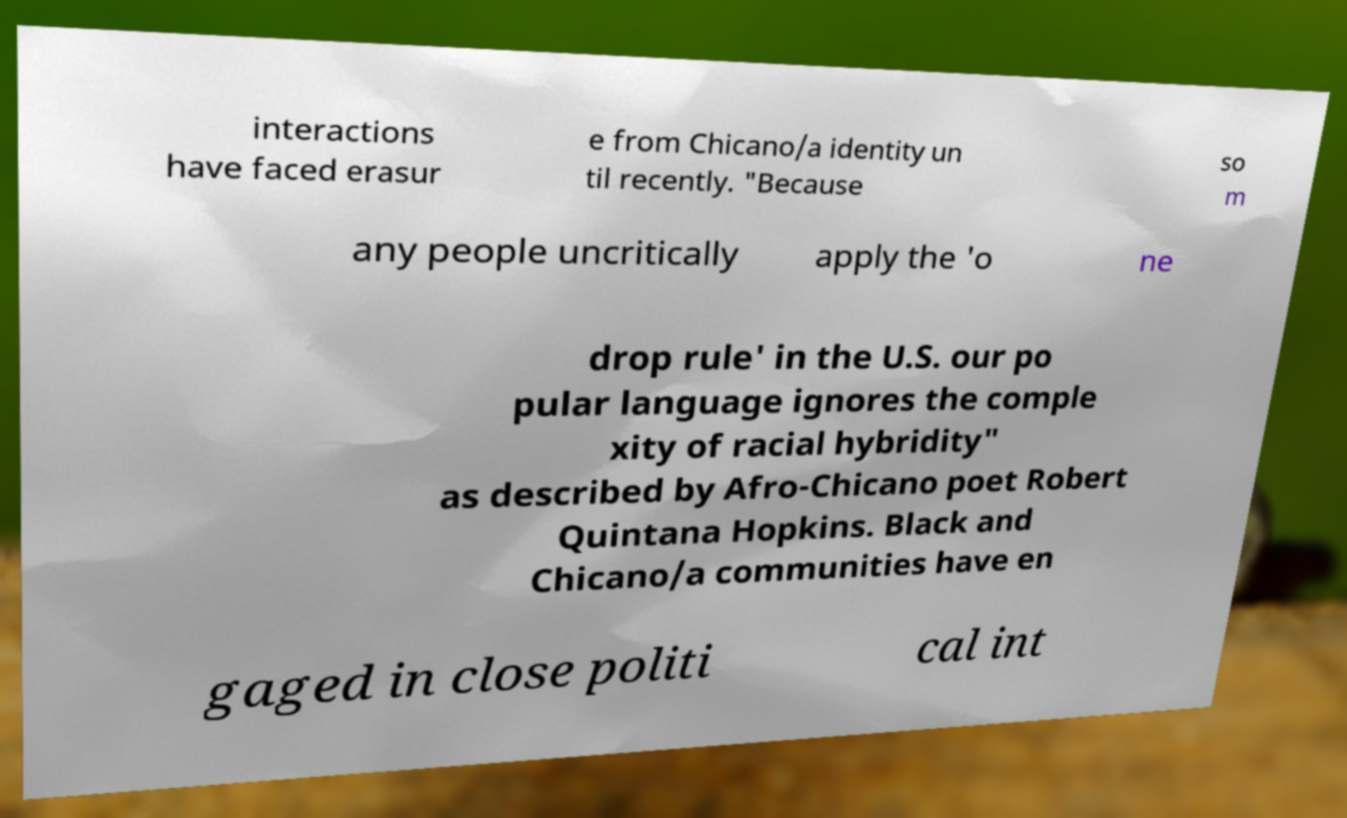Can you accurately transcribe the text from the provided image for me? interactions have faced erasur e from Chicano/a identity un til recently. "Because so m any people uncritically apply the 'o ne drop rule' in the U.S. our po pular language ignores the comple xity of racial hybridity" as described by Afro-Chicano poet Robert Quintana Hopkins. Black and Chicano/a communities have en gaged in close politi cal int 